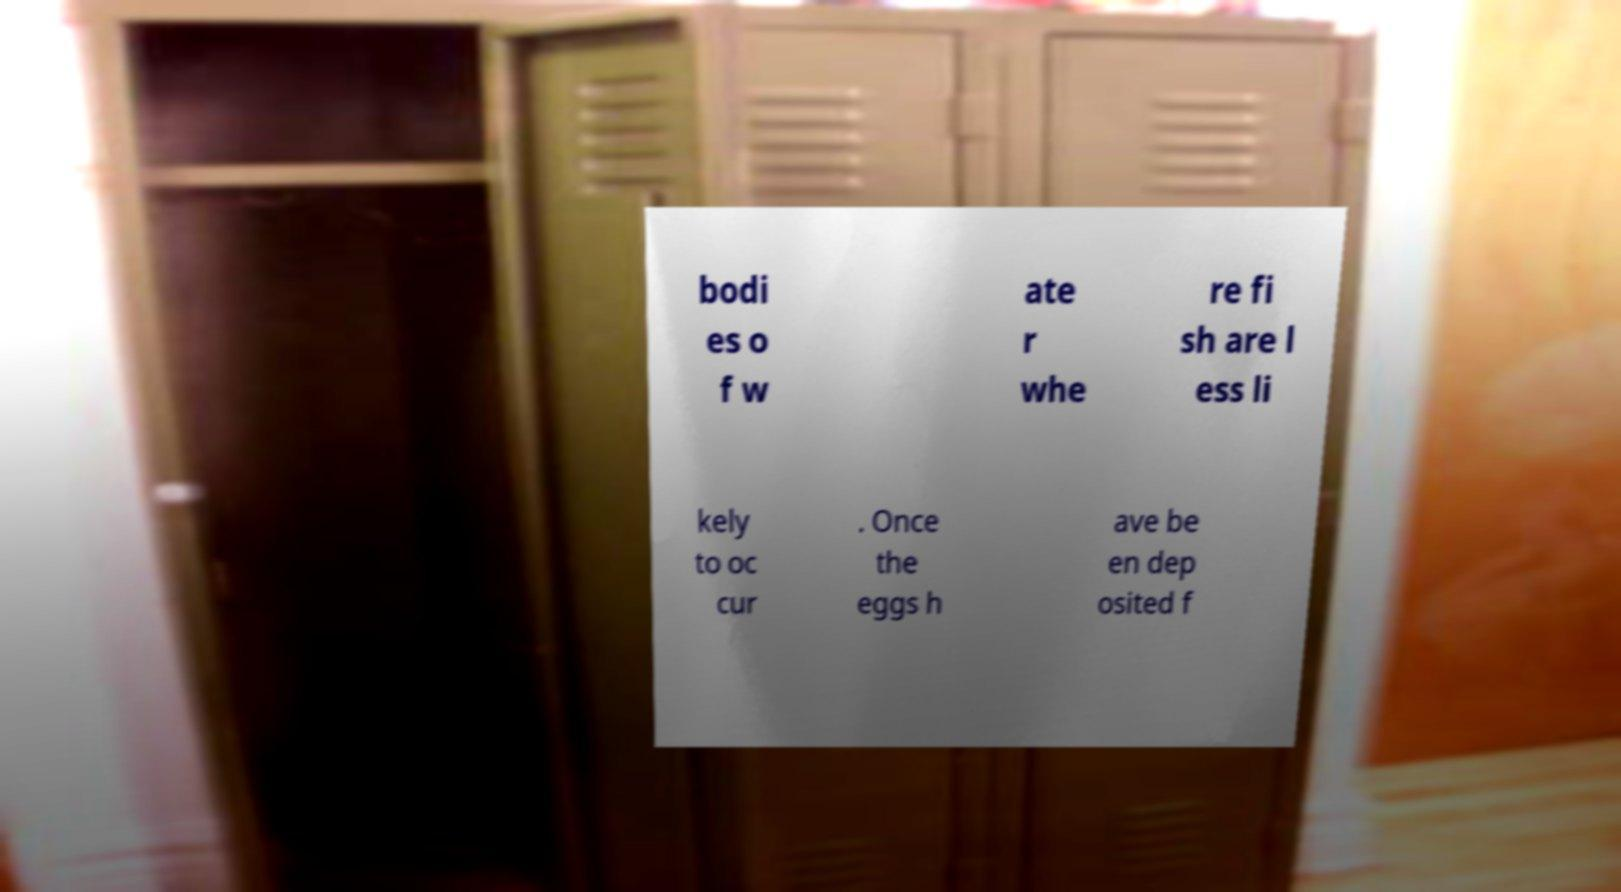What messages or text are displayed in this image? I need them in a readable, typed format. bodi es o f w ate r whe re fi sh are l ess li kely to oc cur . Once the eggs h ave be en dep osited f 